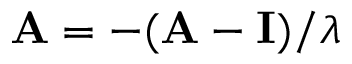<formula> <loc_0><loc_0><loc_500><loc_500>\overset { \triangle d o w n } { A } = - ( \mathbf A - \mathbf I ) / \lambda</formula> 